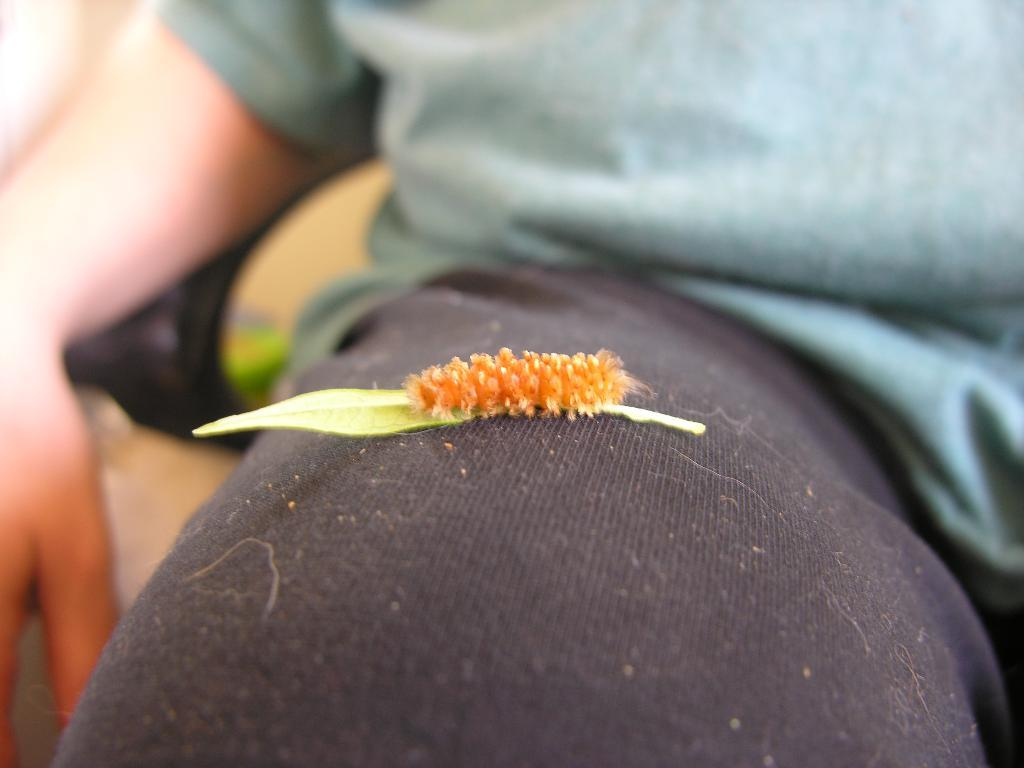What part of a person's body is visible in the image? There is a person's thigh visible in the image. What else can be seen in the image besides the person's thigh? There is an object present in the image. What type of property does the person own in the image? There is no information about property ownership in the image. What kind of vessel is being used by the government in the image? There is no vessel or reference to the government present in the image. 